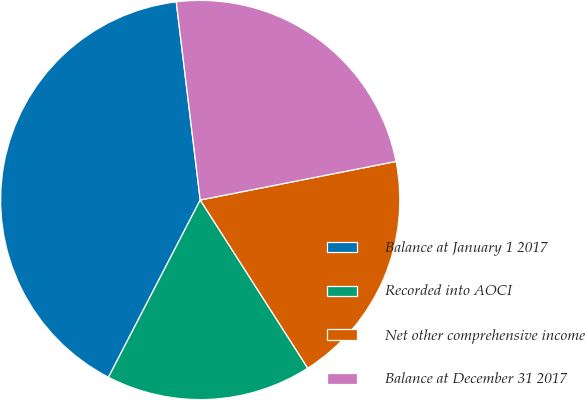Convert chart. <chart><loc_0><loc_0><loc_500><loc_500><pie_chart><fcel>Balance at January 1 2017<fcel>Recorded into AOCI<fcel>Net other comprehensive income<fcel>Balance at December 31 2017<nl><fcel>40.48%<fcel>16.66%<fcel>19.04%<fcel>23.82%<nl></chart> 